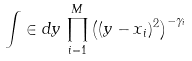<formula> <loc_0><loc_0><loc_500><loc_500>\int \in d y \, \prod _ { i = 1 } ^ { M } \left ( ( y - x _ { i } ) ^ { 2 } \right ) ^ { - \gamma _ { i } }</formula> 